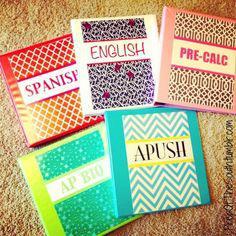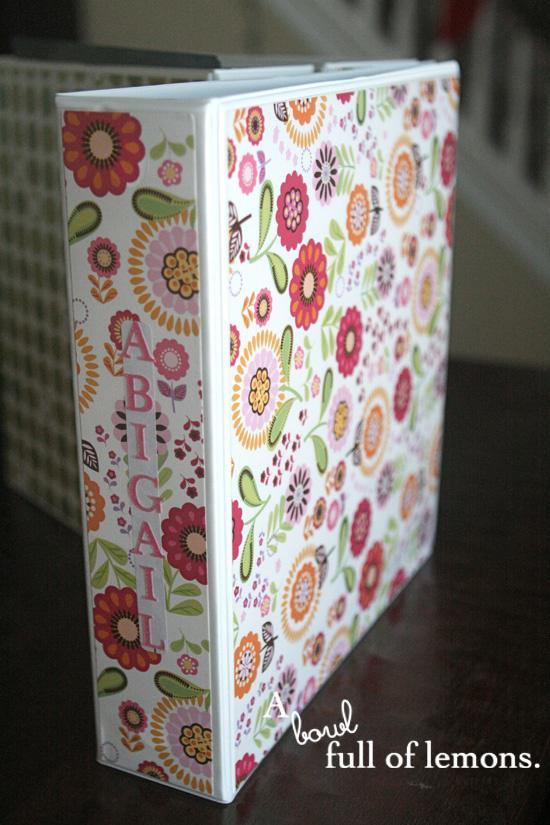The first image is the image on the left, the second image is the image on the right. For the images shown, is this caption "There are five colorful notebooks in one of the images." true? Answer yes or no. Yes. 